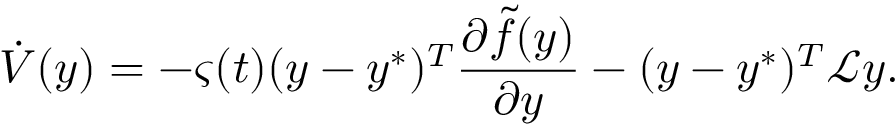Convert formula to latex. <formula><loc_0><loc_0><loc_500><loc_500>\dot { V } ( y ) = - \varsigma ( t ) ( y - y ^ { * } ) ^ { T } \frac { \partial \tilde { f } ( y ) } { \partial y } - ( y - y ^ { * } ) ^ { T } \mathcal { L } y .</formula> 